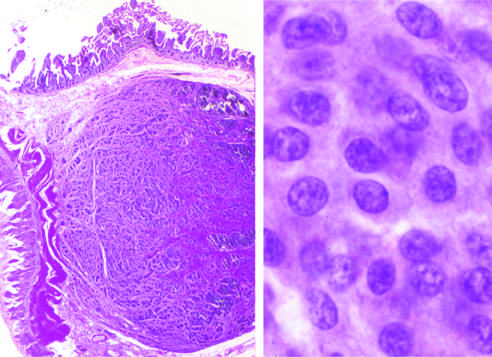does granulomatous host response show the bland cytology that typifies neuroendocrine tumors?
Answer the question using a single word or phrase. No 